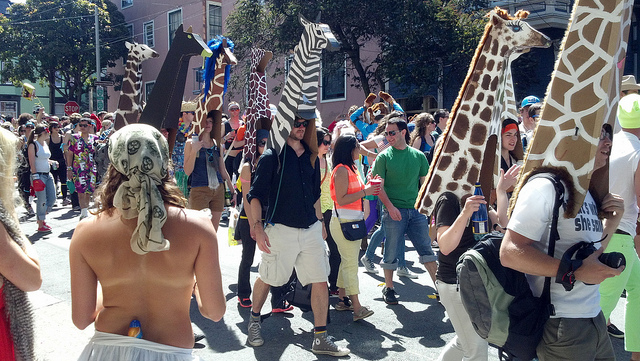Extract all visible text content from this image. she STOP 